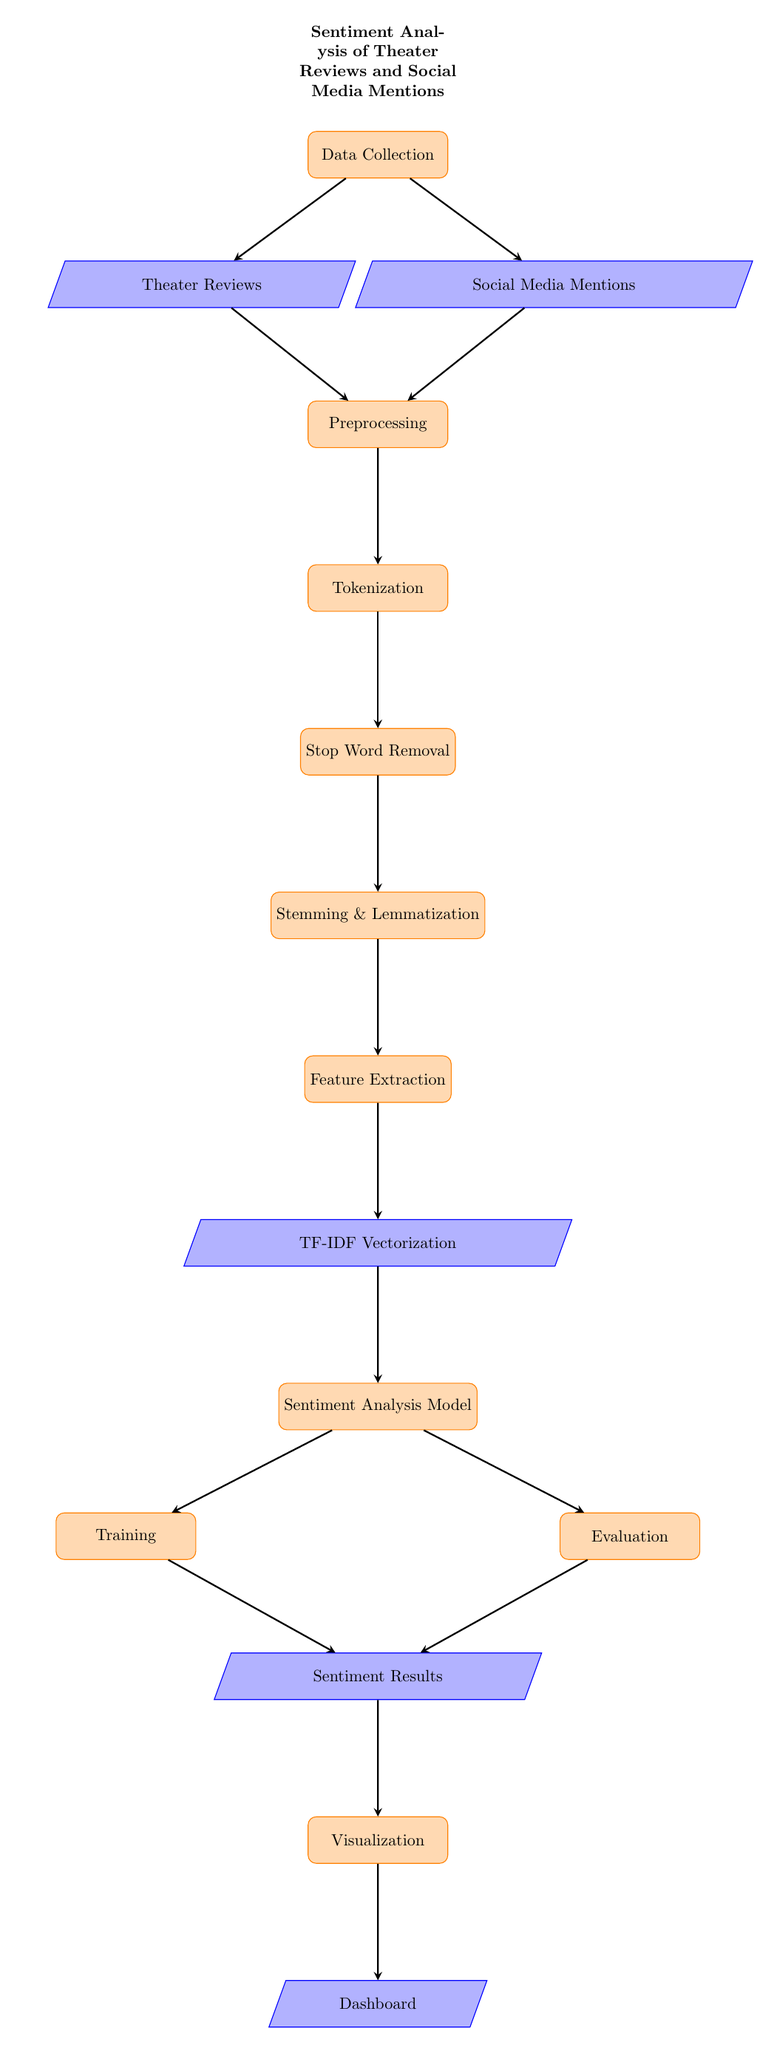What is the first step in the diagram? The first step is labeled as "Data Collection," which indicates the initial phase of the process.
Answer: Data Collection How many preprocessing steps are there? There are four preprocessing steps: Tokenization, Stop Word Removal, Stemming & Lemmatization, and Feature Extraction.
Answer: Four What type of node is "Sentiment Analysis Model"? The "Sentiment Analysis Model" node is a process node, as indicated by its rectangular shape with rounded corners.
Answer: Process What connects "Social Media Mentions" to the subsequent step? "Social Media Mentions" is connected to the "Preprocessing" step, indicating that data from social media will undergo preprocessing before further analysis.
Answer: Preprocessing Which statistical method is used for feature extraction in the diagram? The diagram indicates "TF-IDF Vectorization" is a method for feature extraction, which is a common technique in NLP for transforming text into numerical vectors.
Answer: TF-IDF Vectorization What are the two outcomes of the "Sentiment Analysis Model"? The two outcomes are "Training" and "Evaluation," showing that the model is assessed through these two processes after analysis.
Answer: Training and Evaluation How does the diagram visualize the final output? The final output is visualized as "Dashboard," which is linked to the previous step "Visualization," representing the end of the analysis process.
Answer: Dashboard What follows the "Feature Extraction" step? "TF-IDF Vectorization" follows the "Feature Extraction" step, indicating that this is the method used after features are extracted from the text.
Answer: TF-IDF Vectorization How many nodes represent data in the diagram? There are four nodes representing data: "Theater Reviews," "Social Media Mentions," "TF-IDF Vectorization," and "Sentiment Results."
Answer: Four 